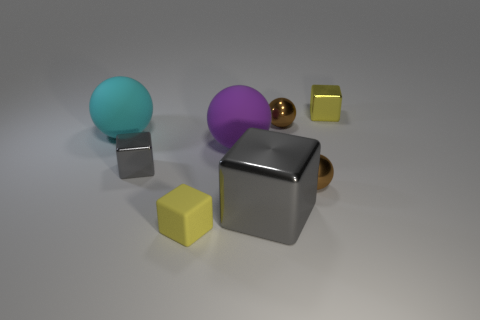How many gray blocks must be subtracted to get 1 gray blocks? 1 Subtract all tiny blocks. How many blocks are left? 1 Subtract 2 blocks. How many blocks are left? 2 Add 6 large cyan matte objects. How many large cyan matte objects exist? 7 Add 1 big gray objects. How many objects exist? 9 Subtract all yellow blocks. How many blocks are left? 2 Subtract 0 gray cylinders. How many objects are left? 8 Subtract all cyan balls. Subtract all brown blocks. How many balls are left? 3 Subtract all gray blocks. How many brown spheres are left? 2 Subtract all cyan cubes. Subtract all brown things. How many objects are left? 6 